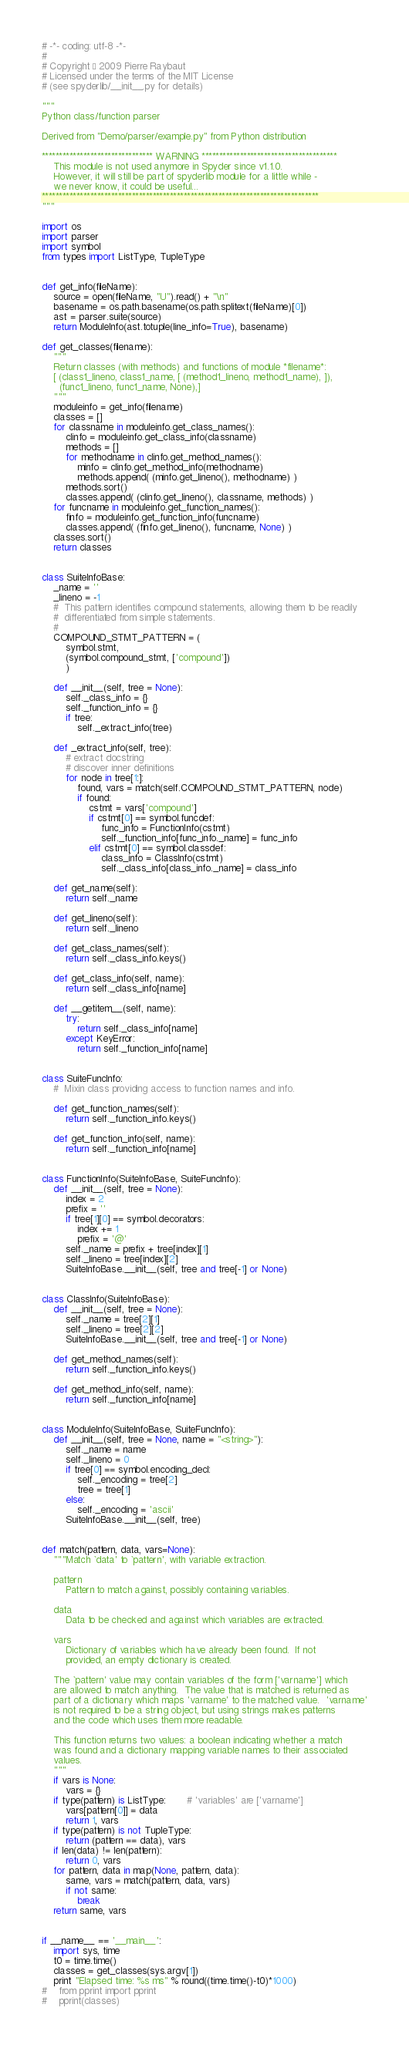<code> <loc_0><loc_0><loc_500><loc_500><_Python_># -*- coding: utf-8 -*-
#
# Copyright © 2009 Pierre Raybaut
# Licensed under the terms of the MIT License
# (see spyderlib/__init__.py for details)

"""
Python class/function parser

Derived from "Demo/parser/example.py" from Python distribution

******************************** WARNING ***************************************
    This module is not used anymore in Spyder since v1.1.0.
    However, it will still be part of spyderlib module for a little while -
    we never know, it could be useful...
********************************************************************************
"""

import os
import parser
import symbol
from types import ListType, TupleType


def get_info(fileName):
    source = open(fileName, "U").read() + "\n"
    basename = os.path.basename(os.path.splitext(fileName)[0])
    ast = parser.suite(source)
    return ModuleInfo(ast.totuple(line_info=True), basename)

def get_classes(filename):
    """
    Return classes (with methods) and functions of module *filename*:
    [ (class1_lineno, class1_name, [ (method1_lineno, method1_name), ]),
      (func1_lineno, func1_name, None),]
    """
    moduleinfo = get_info(filename)
    classes = []
    for classname in moduleinfo.get_class_names():
        clinfo = moduleinfo.get_class_info(classname)
        methods = []
        for methodname in clinfo.get_method_names():
            minfo = clinfo.get_method_info(methodname)
            methods.append( (minfo.get_lineno(), methodname) )
        methods.sort()
        classes.append( (clinfo.get_lineno(), classname, methods) )
    for funcname in moduleinfo.get_function_names():
        finfo = moduleinfo.get_function_info(funcname)
        classes.append( (finfo.get_lineno(), funcname, None) )
    classes.sort()
    return classes


class SuiteInfoBase:
    _name = ''
    _lineno = -1
    #  This pattern identifies compound statements, allowing them to be readily
    #  differentiated from simple statements.
    #
    COMPOUND_STMT_PATTERN = (
        symbol.stmt,
        (symbol.compound_stmt, ['compound'])
        )

    def __init__(self, tree = None):
        self._class_info = {}
        self._function_info = {}
        if tree:
            self._extract_info(tree)

    def _extract_info(self, tree):
        # extract docstring
        # discover inner definitions
        for node in tree[1:]:
            found, vars = match(self.COMPOUND_STMT_PATTERN, node)
            if found:
                cstmt = vars['compound']
                if cstmt[0] == symbol.funcdef:
                    func_info = FunctionInfo(cstmt)
                    self._function_info[func_info._name] = func_info
                elif cstmt[0] == symbol.classdef:
                    class_info = ClassInfo(cstmt)
                    self._class_info[class_info._name] = class_info

    def get_name(self):
        return self._name
        
    def get_lineno(self):
        return self._lineno

    def get_class_names(self):
        return self._class_info.keys()

    def get_class_info(self, name):
        return self._class_info[name]

    def __getitem__(self, name):
        try:
            return self._class_info[name]
        except KeyError:
            return self._function_info[name]


class SuiteFuncInfo:
    #  Mixin class providing access to function names and info.

    def get_function_names(self):
        return self._function_info.keys()

    def get_function_info(self, name):
        return self._function_info[name]


class FunctionInfo(SuiteInfoBase, SuiteFuncInfo):
    def __init__(self, tree = None):
        index = 2
        prefix = ''
        if tree[1][0] == symbol.decorators:
            index += 1
            prefix = '@'
        self._name = prefix + tree[index][1]
        self._lineno = tree[index][2]
        SuiteInfoBase.__init__(self, tree and tree[-1] or None)


class ClassInfo(SuiteInfoBase):
    def __init__(self, tree = None):
        self._name = tree[2][1]
        self._lineno = tree[2][2]
        SuiteInfoBase.__init__(self, tree and tree[-1] or None)

    def get_method_names(self):
        return self._function_info.keys()

    def get_method_info(self, name):
        return self._function_info[name]


class ModuleInfo(SuiteInfoBase, SuiteFuncInfo):
    def __init__(self, tree = None, name = "<string>"):
        self._name = name
        self._lineno = 0
        if tree[0] == symbol.encoding_decl:
            self._encoding = tree[2]
            tree = tree[1]
        else:
            self._encoding = 'ascii'
        SuiteInfoBase.__init__(self, tree)


def match(pattern, data, vars=None):
    """Match `data' to `pattern', with variable extraction.

    pattern
        Pattern to match against, possibly containing variables.

    data
        Data to be checked and against which variables are extracted.

    vars
        Dictionary of variables which have already been found.  If not
        provided, an empty dictionary is created.

    The `pattern' value may contain variables of the form ['varname'] which
    are allowed to match anything.  The value that is matched is returned as
    part of a dictionary which maps 'varname' to the matched value.  'varname'
    is not required to be a string object, but using strings makes patterns
    and the code which uses them more readable.

    This function returns two values: a boolean indicating whether a match
    was found and a dictionary mapping variable names to their associated
    values.
    """
    if vars is None:
        vars = {}
    if type(pattern) is ListType:       # 'variables' are ['varname']
        vars[pattern[0]] = data
        return 1, vars
    if type(pattern) is not TupleType:
        return (pattern == data), vars
    if len(data) != len(pattern):
        return 0, vars
    for pattern, data in map(None, pattern, data):
        same, vars = match(pattern, data, vars)
        if not same:
            break
    return same, vars


if __name__ == '__main__':
    import sys, time
    t0 = time.time()
    classes = get_classes(sys.argv[1])
    print "Elapsed time: %s ms" % round((time.time()-t0)*1000)
#    from pprint import pprint
#    pprint(classes)
</code> 